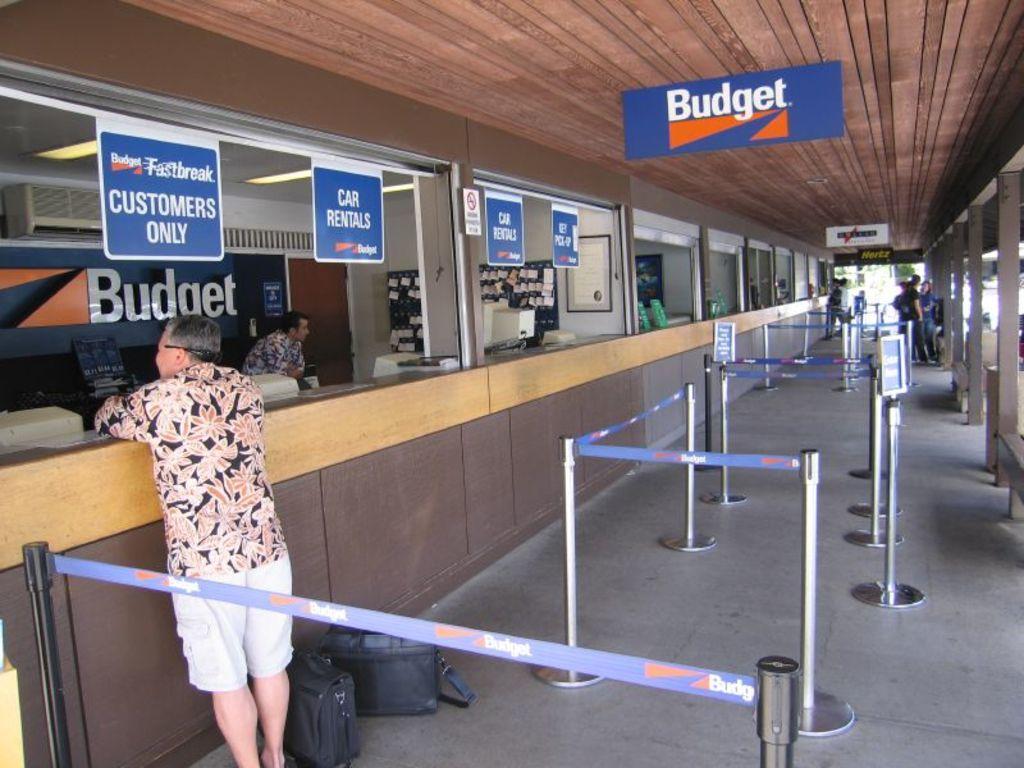How would you summarize this image in a sentence or two? In the image, it seems to be a travel agency, an old man standing on the left side in front of the table, in front there are railings and the ceiling is of wood , there is system,racks and boards inside the hall. 